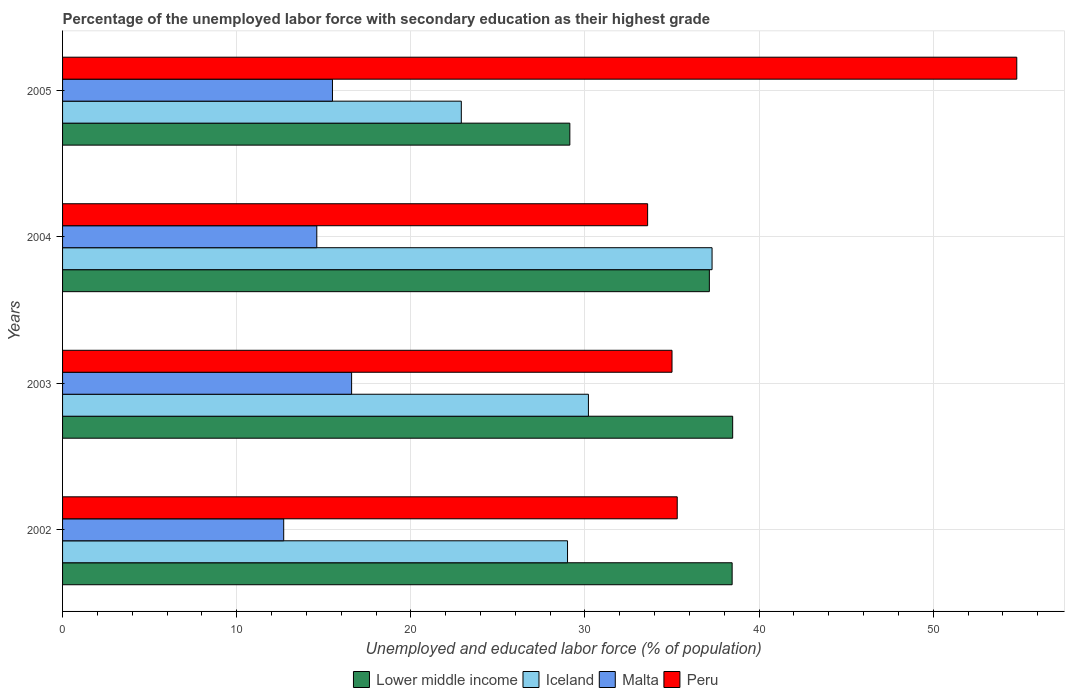How many groups of bars are there?
Give a very brief answer. 4. Are the number of bars per tick equal to the number of legend labels?
Your answer should be compact. Yes. How many bars are there on the 4th tick from the bottom?
Provide a succinct answer. 4. What is the label of the 1st group of bars from the top?
Provide a succinct answer. 2005. What is the percentage of the unemployed labor force with secondary education in Peru in 2002?
Provide a succinct answer. 35.3. Across all years, what is the maximum percentage of the unemployed labor force with secondary education in Iceland?
Your response must be concise. 37.3. Across all years, what is the minimum percentage of the unemployed labor force with secondary education in Peru?
Your answer should be compact. 33.6. In which year was the percentage of the unemployed labor force with secondary education in Peru minimum?
Your answer should be very brief. 2004. What is the total percentage of the unemployed labor force with secondary education in Malta in the graph?
Offer a very short reply. 59.4. What is the difference between the percentage of the unemployed labor force with secondary education in Peru in 2002 and that in 2005?
Make the answer very short. -19.5. What is the difference between the percentage of the unemployed labor force with secondary education in Lower middle income in 2004 and the percentage of the unemployed labor force with secondary education in Iceland in 2002?
Keep it short and to the point. 8.14. What is the average percentage of the unemployed labor force with secondary education in Peru per year?
Ensure brevity in your answer.  39.67. In the year 2002, what is the difference between the percentage of the unemployed labor force with secondary education in Malta and percentage of the unemployed labor force with secondary education in Lower middle income?
Ensure brevity in your answer.  -25.75. In how many years, is the percentage of the unemployed labor force with secondary education in Lower middle income greater than 12 %?
Make the answer very short. 4. What is the ratio of the percentage of the unemployed labor force with secondary education in Lower middle income in 2004 to that in 2005?
Keep it short and to the point. 1.28. Is the percentage of the unemployed labor force with secondary education in Peru in 2004 less than that in 2005?
Provide a short and direct response. Yes. What is the difference between the highest and the second highest percentage of the unemployed labor force with secondary education in Malta?
Your answer should be very brief. 1.1. What is the difference between the highest and the lowest percentage of the unemployed labor force with secondary education in Iceland?
Provide a short and direct response. 14.4. In how many years, is the percentage of the unemployed labor force with secondary education in Lower middle income greater than the average percentage of the unemployed labor force with secondary education in Lower middle income taken over all years?
Your answer should be very brief. 3. Is it the case that in every year, the sum of the percentage of the unemployed labor force with secondary education in Malta and percentage of the unemployed labor force with secondary education in Peru is greater than the sum of percentage of the unemployed labor force with secondary education in Iceland and percentage of the unemployed labor force with secondary education in Lower middle income?
Your response must be concise. No. What does the 2nd bar from the top in 2005 represents?
Your answer should be very brief. Malta. What does the 1st bar from the bottom in 2002 represents?
Your response must be concise. Lower middle income. Is it the case that in every year, the sum of the percentage of the unemployed labor force with secondary education in Malta and percentage of the unemployed labor force with secondary education in Peru is greater than the percentage of the unemployed labor force with secondary education in Iceland?
Provide a succinct answer. Yes. How many bars are there?
Give a very brief answer. 16. How many years are there in the graph?
Make the answer very short. 4. What is the difference between two consecutive major ticks on the X-axis?
Provide a succinct answer. 10. Does the graph contain any zero values?
Offer a very short reply. No. Does the graph contain grids?
Your answer should be very brief. Yes. Where does the legend appear in the graph?
Your answer should be very brief. Bottom center. How many legend labels are there?
Offer a very short reply. 4. How are the legend labels stacked?
Your answer should be very brief. Horizontal. What is the title of the graph?
Your answer should be compact. Percentage of the unemployed labor force with secondary education as their highest grade. Does "East Asia (all income levels)" appear as one of the legend labels in the graph?
Your answer should be compact. No. What is the label or title of the X-axis?
Give a very brief answer. Unemployed and educated labor force (% of population). What is the label or title of the Y-axis?
Offer a very short reply. Years. What is the Unemployed and educated labor force (% of population) of Lower middle income in 2002?
Your answer should be compact. 38.45. What is the Unemployed and educated labor force (% of population) of Iceland in 2002?
Your response must be concise. 29. What is the Unemployed and educated labor force (% of population) of Malta in 2002?
Ensure brevity in your answer.  12.7. What is the Unemployed and educated labor force (% of population) of Peru in 2002?
Your answer should be compact. 35.3. What is the Unemployed and educated labor force (% of population) of Lower middle income in 2003?
Make the answer very short. 38.48. What is the Unemployed and educated labor force (% of population) in Iceland in 2003?
Make the answer very short. 30.2. What is the Unemployed and educated labor force (% of population) of Malta in 2003?
Make the answer very short. 16.6. What is the Unemployed and educated labor force (% of population) of Peru in 2003?
Provide a short and direct response. 35. What is the Unemployed and educated labor force (% of population) of Lower middle income in 2004?
Provide a short and direct response. 37.14. What is the Unemployed and educated labor force (% of population) in Iceland in 2004?
Offer a very short reply. 37.3. What is the Unemployed and educated labor force (% of population) in Malta in 2004?
Offer a very short reply. 14.6. What is the Unemployed and educated labor force (% of population) of Peru in 2004?
Give a very brief answer. 33.6. What is the Unemployed and educated labor force (% of population) in Lower middle income in 2005?
Your response must be concise. 29.13. What is the Unemployed and educated labor force (% of population) of Iceland in 2005?
Provide a short and direct response. 22.9. What is the Unemployed and educated labor force (% of population) in Peru in 2005?
Ensure brevity in your answer.  54.8. Across all years, what is the maximum Unemployed and educated labor force (% of population) in Lower middle income?
Ensure brevity in your answer.  38.48. Across all years, what is the maximum Unemployed and educated labor force (% of population) of Iceland?
Provide a succinct answer. 37.3. Across all years, what is the maximum Unemployed and educated labor force (% of population) of Malta?
Give a very brief answer. 16.6. Across all years, what is the maximum Unemployed and educated labor force (% of population) in Peru?
Offer a very short reply. 54.8. Across all years, what is the minimum Unemployed and educated labor force (% of population) in Lower middle income?
Ensure brevity in your answer.  29.13. Across all years, what is the minimum Unemployed and educated labor force (% of population) of Iceland?
Your answer should be very brief. 22.9. Across all years, what is the minimum Unemployed and educated labor force (% of population) in Malta?
Make the answer very short. 12.7. Across all years, what is the minimum Unemployed and educated labor force (% of population) in Peru?
Offer a terse response. 33.6. What is the total Unemployed and educated labor force (% of population) in Lower middle income in the graph?
Give a very brief answer. 143.21. What is the total Unemployed and educated labor force (% of population) of Iceland in the graph?
Provide a short and direct response. 119.4. What is the total Unemployed and educated labor force (% of population) in Malta in the graph?
Keep it short and to the point. 59.4. What is the total Unemployed and educated labor force (% of population) in Peru in the graph?
Provide a short and direct response. 158.7. What is the difference between the Unemployed and educated labor force (% of population) in Lower middle income in 2002 and that in 2003?
Provide a short and direct response. -0.03. What is the difference between the Unemployed and educated labor force (% of population) in Peru in 2002 and that in 2003?
Provide a short and direct response. 0.3. What is the difference between the Unemployed and educated labor force (% of population) in Lower middle income in 2002 and that in 2004?
Make the answer very short. 1.31. What is the difference between the Unemployed and educated labor force (% of population) in Malta in 2002 and that in 2004?
Provide a short and direct response. -1.9. What is the difference between the Unemployed and educated labor force (% of population) in Lower middle income in 2002 and that in 2005?
Give a very brief answer. 9.32. What is the difference between the Unemployed and educated labor force (% of population) in Iceland in 2002 and that in 2005?
Make the answer very short. 6.1. What is the difference between the Unemployed and educated labor force (% of population) of Peru in 2002 and that in 2005?
Your answer should be very brief. -19.5. What is the difference between the Unemployed and educated labor force (% of population) of Lower middle income in 2003 and that in 2004?
Provide a succinct answer. 1.34. What is the difference between the Unemployed and educated labor force (% of population) in Lower middle income in 2003 and that in 2005?
Keep it short and to the point. 9.35. What is the difference between the Unemployed and educated labor force (% of population) in Peru in 2003 and that in 2005?
Keep it short and to the point. -19.8. What is the difference between the Unemployed and educated labor force (% of population) in Lower middle income in 2004 and that in 2005?
Make the answer very short. 8.01. What is the difference between the Unemployed and educated labor force (% of population) of Peru in 2004 and that in 2005?
Your answer should be compact. -21.2. What is the difference between the Unemployed and educated labor force (% of population) of Lower middle income in 2002 and the Unemployed and educated labor force (% of population) of Iceland in 2003?
Offer a terse response. 8.25. What is the difference between the Unemployed and educated labor force (% of population) in Lower middle income in 2002 and the Unemployed and educated labor force (% of population) in Malta in 2003?
Provide a succinct answer. 21.85. What is the difference between the Unemployed and educated labor force (% of population) in Lower middle income in 2002 and the Unemployed and educated labor force (% of population) in Peru in 2003?
Provide a short and direct response. 3.45. What is the difference between the Unemployed and educated labor force (% of population) of Iceland in 2002 and the Unemployed and educated labor force (% of population) of Malta in 2003?
Your answer should be compact. 12.4. What is the difference between the Unemployed and educated labor force (% of population) of Iceland in 2002 and the Unemployed and educated labor force (% of population) of Peru in 2003?
Offer a very short reply. -6. What is the difference between the Unemployed and educated labor force (% of population) in Malta in 2002 and the Unemployed and educated labor force (% of population) in Peru in 2003?
Keep it short and to the point. -22.3. What is the difference between the Unemployed and educated labor force (% of population) in Lower middle income in 2002 and the Unemployed and educated labor force (% of population) in Iceland in 2004?
Your answer should be compact. 1.15. What is the difference between the Unemployed and educated labor force (% of population) of Lower middle income in 2002 and the Unemployed and educated labor force (% of population) of Malta in 2004?
Keep it short and to the point. 23.85. What is the difference between the Unemployed and educated labor force (% of population) in Lower middle income in 2002 and the Unemployed and educated labor force (% of population) in Peru in 2004?
Offer a terse response. 4.85. What is the difference between the Unemployed and educated labor force (% of population) of Iceland in 2002 and the Unemployed and educated labor force (% of population) of Peru in 2004?
Provide a short and direct response. -4.6. What is the difference between the Unemployed and educated labor force (% of population) in Malta in 2002 and the Unemployed and educated labor force (% of population) in Peru in 2004?
Offer a very short reply. -20.9. What is the difference between the Unemployed and educated labor force (% of population) in Lower middle income in 2002 and the Unemployed and educated labor force (% of population) in Iceland in 2005?
Give a very brief answer. 15.55. What is the difference between the Unemployed and educated labor force (% of population) of Lower middle income in 2002 and the Unemployed and educated labor force (% of population) of Malta in 2005?
Make the answer very short. 22.95. What is the difference between the Unemployed and educated labor force (% of population) in Lower middle income in 2002 and the Unemployed and educated labor force (% of population) in Peru in 2005?
Provide a succinct answer. -16.35. What is the difference between the Unemployed and educated labor force (% of population) of Iceland in 2002 and the Unemployed and educated labor force (% of population) of Malta in 2005?
Provide a succinct answer. 13.5. What is the difference between the Unemployed and educated labor force (% of population) in Iceland in 2002 and the Unemployed and educated labor force (% of population) in Peru in 2005?
Make the answer very short. -25.8. What is the difference between the Unemployed and educated labor force (% of population) of Malta in 2002 and the Unemployed and educated labor force (% of population) of Peru in 2005?
Your answer should be compact. -42.1. What is the difference between the Unemployed and educated labor force (% of population) of Lower middle income in 2003 and the Unemployed and educated labor force (% of population) of Iceland in 2004?
Provide a short and direct response. 1.18. What is the difference between the Unemployed and educated labor force (% of population) in Lower middle income in 2003 and the Unemployed and educated labor force (% of population) in Malta in 2004?
Your answer should be compact. 23.88. What is the difference between the Unemployed and educated labor force (% of population) in Lower middle income in 2003 and the Unemployed and educated labor force (% of population) in Peru in 2004?
Your answer should be very brief. 4.88. What is the difference between the Unemployed and educated labor force (% of population) of Iceland in 2003 and the Unemployed and educated labor force (% of population) of Malta in 2004?
Offer a very short reply. 15.6. What is the difference between the Unemployed and educated labor force (% of population) of Lower middle income in 2003 and the Unemployed and educated labor force (% of population) of Iceland in 2005?
Keep it short and to the point. 15.58. What is the difference between the Unemployed and educated labor force (% of population) in Lower middle income in 2003 and the Unemployed and educated labor force (% of population) in Malta in 2005?
Ensure brevity in your answer.  22.98. What is the difference between the Unemployed and educated labor force (% of population) in Lower middle income in 2003 and the Unemployed and educated labor force (% of population) in Peru in 2005?
Provide a short and direct response. -16.32. What is the difference between the Unemployed and educated labor force (% of population) in Iceland in 2003 and the Unemployed and educated labor force (% of population) in Malta in 2005?
Ensure brevity in your answer.  14.7. What is the difference between the Unemployed and educated labor force (% of population) of Iceland in 2003 and the Unemployed and educated labor force (% of population) of Peru in 2005?
Keep it short and to the point. -24.6. What is the difference between the Unemployed and educated labor force (% of population) of Malta in 2003 and the Unemployed and educated labor force (% of population) of Peru in 2005?
Offer a terse response. -38.2. What is the difference between the Unemployed and educated labor force (% of population) in Lower middle income in 2004 and the Unemployed and educated labor force (% of population) in Iceland in 2005?
Provide a short and direct response. 14.24. What is the difference between the Unemployed and educated labor force (% of population) of Lower middle income in 2004 and the Unemployed and educated labor force (% of population) of Malta in 2005?
Offer a terse response. 21.64. What is the difference between the Unemployed and educated labor force (% of population) of Lower middle income in 2004 and the Unemployed and educated labor force (% of population) of Peru in 2005?
Give a very brief answer. -17.66. What is the difference between the Unemployed and educated labor force (% of population) in Iceland in 2004 and the Unemployed and educated labor force (% of population) in Malta in 2005?
Keep it short and to the point. 21.8. What is the difference between the Unemployed and educated labor force (% of population) of Iceland in 2004 and the Unemployed and educated labor force (% of population) of Peru in 2005?
Provide a succinct answer. -17.5. What is the difference between the Unemployed and educated labor force (% of population) in Malta in 2004 and the Unemployed and educated labor force (% of population) in Peru in 2005?
Your answer should be compact. -40.2. What is the average Unemployed and educated labor force (% of population) in Lower middle income per year?
Ensure brevity in your answer.  35.8. What is the average Unemployed and educated labor force (% of population) in Iceland per year?
Your response must be concise. 29.85. What is the average Unemployed and educated labor force (% of population) of Malta per year?
Offer a terse response. 14.85. What is the average Unemployed and educated labor force (% of population) in Peru per year?
Make the answer very short. 39.67. In the year 2002, what is the difference between the Unemployed and educated labor force (% of population) of Lower middle income and Unemployed and educated labor force (% of population) of Iceland?
Your answer should be very brief. 9.45. In the year 2002, what is the difference between the Unemployed and educated labor force (% of population) in Lower middle income and Unemployed and educated labor force (% of population) in Malta?
Your response must be concise. 25.75. In the year 2002, what is the difference between the Unemployed and educated labor force (% of population) in Lower middle income and Unemployed and educated labor force (% of population) in Peru?
Your answer should be compact. 3.15. In the year 2002, what is the difference between the Unemployed and educated labor force (% of population) of Malta and Unemployed and educated labor force (% of population) of Peru?
Offer a very short reply. -22.6. In the year 2003, what is the difference between the Unemployed and educated labor force (% of population) of Lower middle income and Unemployed and educated labor force (% of population) of Iceland?
Ensure brevity in your answer.  8.28. In the year 2003, what is the difference between the Unemployed and educated labor force (% of population) of Lower middle income and Unemployed and educated labor force (% of population) of Malta?
Your answer should be compact. 21.88. In the year 2003, what is the difference between the Unemployed and educated labor force (% of population) in Lower middle income and Unemployed and educated labor force (% of population) in Peru?
Your response must be concise. 3.48. In the year 2003, what is the difference between the Unemployed and educated labor force (% of population) in Iceland and Unemployed and educated labor force (% of population) in Peru?
Give a very brief answer. -4.8. In the year 2003, what is the difference between the Unemployed and educated labor force (% of population) in Malta and Unemployed and educated labor force (% of population) in Peru?
Your response must be concise. -18.4. In the year 2004, what is the difference between the Unemployed and educated labor force (% of population) in Lower middle income and Unemployed and educated labor force (% of population) in Iceland?
Your answer should be compact. -0.16. In the year 2004, what is the difference between the Unemployed and educated labor force (% of population) in Lower middle income and Unemployed and educated labor force (% of population) in Malta?
Offer a very short reply. 22.54. In the year 2004, what is the difference between the Unemployed and educated labor force (% of population) of Lower middle income and Unemployed and educated labor force (% of population) of Peru?
Provide a short and direct response. 3.54. In the year 2004, what is the difference between the Unemployed and educated labor force (% of population) in Iceland and Unemployed and educated labor force (% of population) in Malta?
Keep it short and to the point. 22.7. In the year 2004, what is the difference between the Unemployed and educated labor force (% of population) in Malta and Unemployed and educated labor force (% of population) in Peru?
Offer a terse response. -19. In the year 2005, what is the difference between the Unemployed and educated labor force (% of population) of Lower middle income and Unemployed and educated labor force (% of population) of Iceland?
Provide a succinct answer. 6.23. In the year 2005, what is the difference between the Unemployed and educated labor force (% of population) in Lower middle income and Unemployed and educated labor force (% of population) in Malta?
Ensure brevity in your answer.  13.63. In the year 2005, what is the difference between the Unemployed and educated labor force (% of population) in Lower middle income and Unemployed and educated labor force (% of population) in Peru?
Offer a very short reply. -25.67. In the year 2005, what is the difference between the Unemployed and educated labor force (% of population) of Iceland and Unemployed and educated labor force (% of population) of Peru?
Your response must be concise. -31.9. In the year 2005, what is the difference between the Unemployed and educated labor force (% of population) of Malta and Unemployed and educated labor force (% of population) of Peru?
Offer a very short reply. -39.3. What is the ratio of the Unemployed and educated labor force (% of population) in Iceland in 2002 to that in 2003?
Your answer should be compact. 0.96. What is the ratio of the Unemployed and educated labor force (% of population) of Malta in 2002 to that in 2003?
Keep it short and to the point. 0.77. What is the ratio of the Unemployed and educated labor force (% of population) of Peru in 2002 to that in 2003?
Give a very brief answer. 1.01. What is the ratio of the Unemployed and educated labor force (% of population) in Lower middle income in 2002 to that in 2004?
Offer a terse response. 1.04. What is the ratio of the Unemployed and educated labor force (% of population) of Iceland in 2002 to that in 2004?
Provide a short and direct response. 0.78. What is the ratio of the Unemployed and educated labor force (% of population) in Malta in 2002 to that in 2004?
Your response must be concise. 0.87. What is the ratio of the Unemployed and educated labor force (% of population) in Peru in 2002 to that in 2004?
Give a very brief answer. 1.05. What is the ratio of the Unemployed and educated labor force (% of population) in Lower middle income in 2002 to that in 2005?
Provide a short and direct response. 1.32. What is the ratio of the Unemployed and educated labor force (% of population) of Iceland in 2002 to that in 2005?
Your answer should be very brief. 1.27. What is the ratio of the Unemployed and educated labor force (% of population) of Malta in 2002 to that in 2005?
Keep it short and to the point. 0.82. What is the ratio of the Unemployed and educated labor force (% of population) in Peru in 2002 to that in 2005?
Give a very brief answer. 0.64. What is the ratio of the Unemployed and educated labor force (% of population) of Lower middle income in 2003 to that in 2004?
Your response must be concise. 1.04. What is the ratio of the Unemployed and educated labor force (% of population) in Iceland in 2003 to that in 2004?
Provide a short and direct response. 0.81. What is the ratio of the Unemployed and educated labor force (% of population) in Malta in 2003 to that in 2004?
Your answer should be compact. 1.14. What is the ratio of the Unemployed and educated labor force (% of population) in Peru in 2003 to that in 2004?
Your response must be concise. 1.04. What is the ratio of the Unemployed and educated labor force (% of population) in Lower middle income in 2003 to that in 2005?
Ensure brevity in your answer.  1.32. What is the ratio of the Unemployed and educated labor force (% of population) of Iceland in 2003 to that in 2005?
Give a very brief answer. 1.32. What is the ratio of the Unemployed and educated labor force (% of population) of Malta in 2003 to that in 2005?
Provide a short and direct response. 1.07. What is the ratio of the Unemployed and educated labor force (% of population) of Peru in 2003 to that in 2005?
Provide a short and direct response. 0.64. What is the ratio of the Unemployed and educated labor force (% of population) in Lower middle income in 2004 to that in 2005?
Your answer should be very brief. 1.27. What is the ratio of the Unemployed and educated labor force (% of population) in Iceland in 2004 to that in 2005?
Make the answer very short. 1.63. What is the ratio of the Unemployed and educated labor force (% of population) in Malta in 2004 to that in 2005?
Your response must be concise. 0.94. What is the ratio of the Unemployed and educated labor force (% of population) of Peru in 2004 to that in 2005?
Provide a succinct answer. 0.61. What is the difference between the highest and the second highest Unemployed and educated labor force (% of population) of Lower middle income?
Your response must be concise. 0.03. What is the difference between the highest and the second highest Unemployed and educated labor force (% of population) in Iceland?
Offer a very short reply. 7.1. What is the difference between the highest and the second highest Unemployed and educated labor force (% of population) in Malta?
Keep it short and to the point. 1.1. What is the difference between the highest and the second highest Unemployed and educated labor force (% of population) of Peru?
Your answer should be compact. 19.5. What is the difference between the highest and the lowest Unemployed and educated labor force (% of population) of Lower middle income?
Ensure brevity in your answer.  9.35. What is the difference between the highest and the lowest Unemployed and educated labor force (% of population) of Peru?
Your answer should be compact. 21.2. 